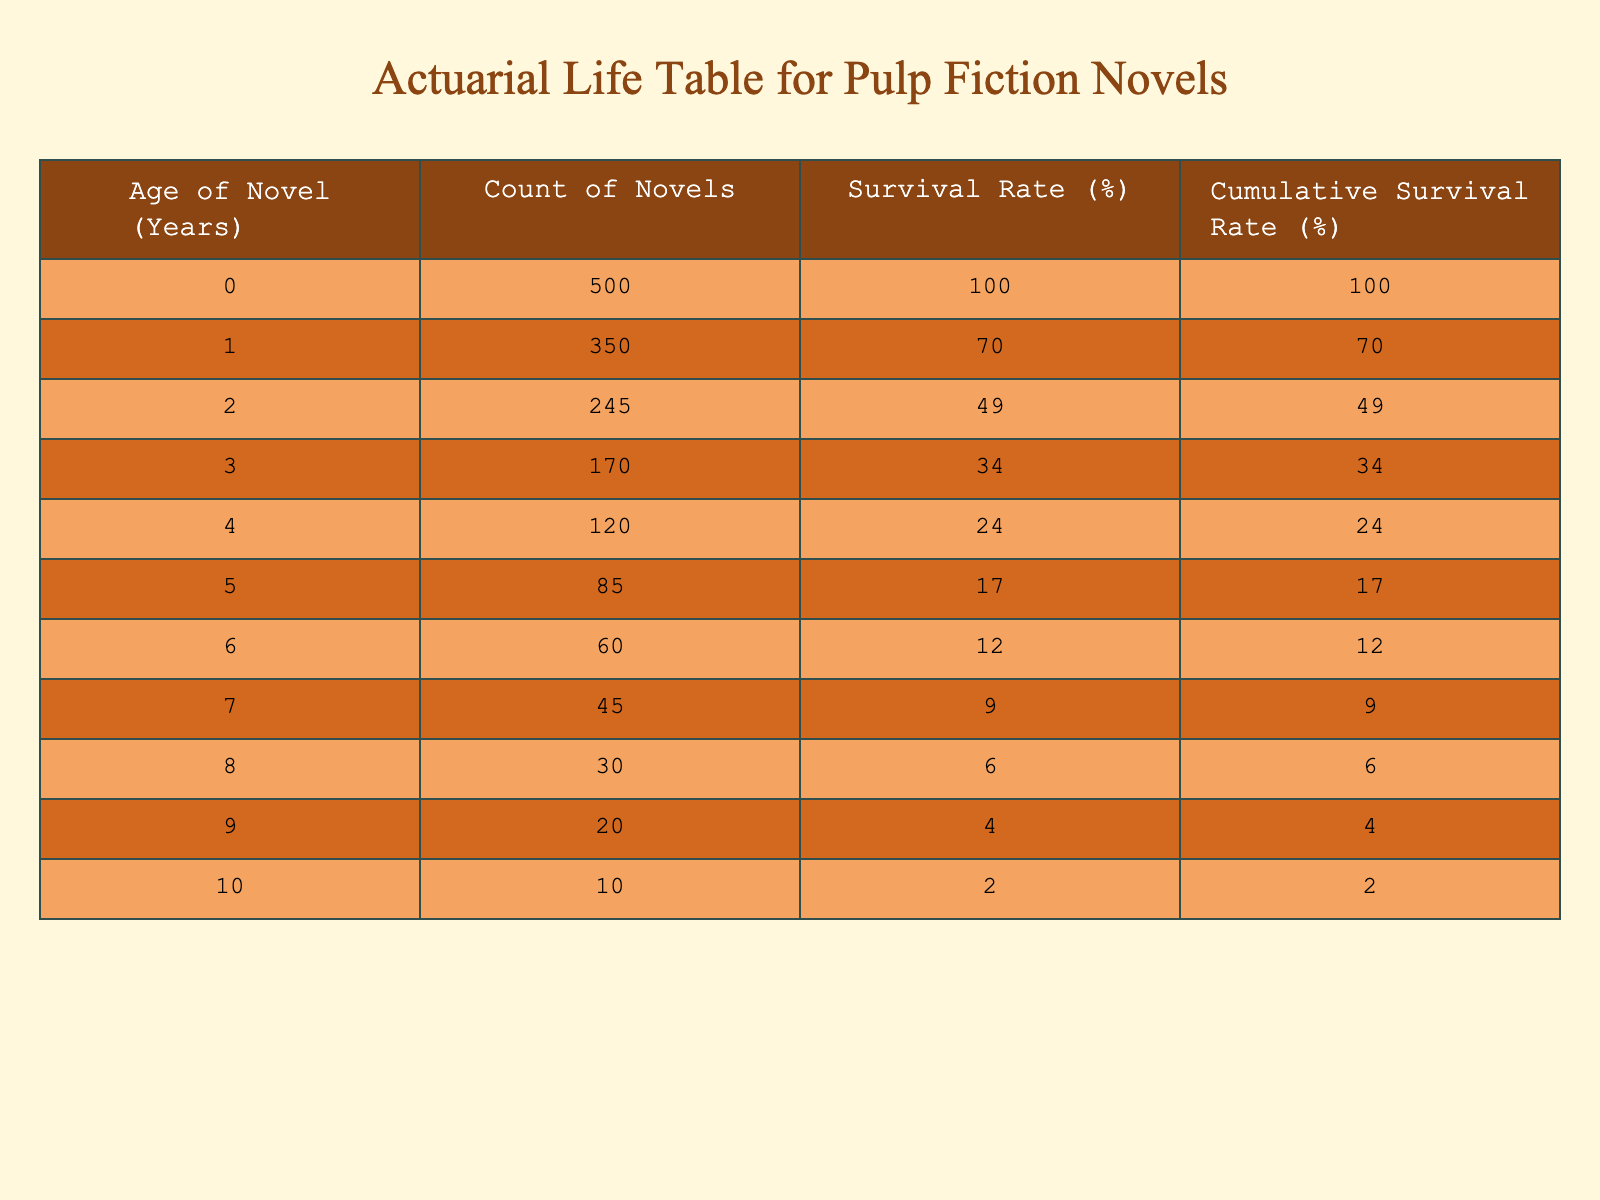What is the survival rate of debut novels after 5 years? According to the table, the survival rate for novels aged 5 years is 17%.
Answer: 17% How many novels survive after 3 years? The count of novels that survive after 3 years is 170, as indicated in the table.
Answer: 170 What is the cumulative survival rate for novels after 6 years? The cumulative survival rate after 6 years is 12%, as shown in the table.
Answer: 12% What is the total count of novels that survived up to 4 years? To find this, we look at the counts for ages 0 to 4. Adding them gives us 500 + 350 + 245 + 170 + 120 = 1385.
Answer: 1385 Do more than half of the debut novels survive past their first year? Yes, since 350 novels out of 500 survive the first year, which is 70%. This is more than half.
Answer: Yes What is the difference in survival rates between novels aged 1 year and 3 years? The survival rate for 1 year is 70%, and for 3 years, it is 34%. The difference is 70 - 34 = 36%.
Answer: 36% What percentage of novels are still surviving after 9 years compared to the total count at 0 years? The survival rate after 9 years is 4%, which is (20 / 500) * 100 = 4%. Thus, it shows that only 4% of the debut novels are surviving compared to the initial total.
Answer: 4% What is the average survival rate of novels from ages 0 to 4? First, we find the survival rates for ages 0 to 4, which are 100%, 70%, 49%, 34%, and 24%. Adding these gives 100 + 70 + 49 + 34 + 24 = 277. Dividing by 5 (the number of years) gives 277 / 5 = 55.4%.
Answer: 55.4% How many novels from the batch originally published are no longer surviving by year 10? Initially, there were 500 debut novels; by year 10, only 10 survive. Thus, the number of novels that have ceased to exist is 500 - 10 = 490.
Answer: 490 